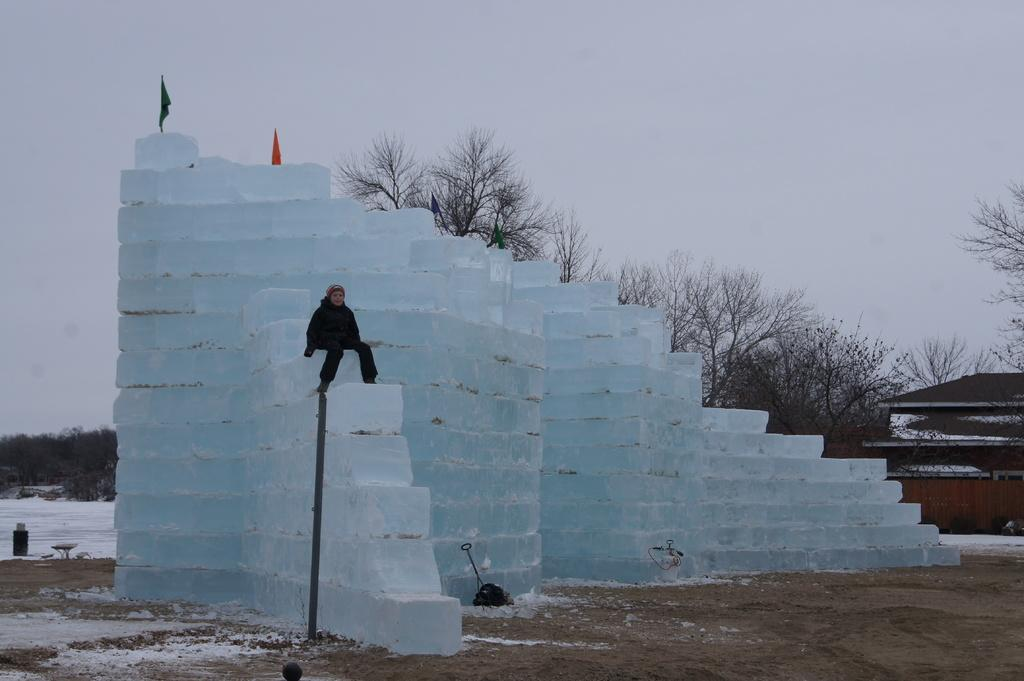What type of structure is visible in the image? There is a house in the image. What natural elements can be seen in the image? There are trees and snow on the ground in the image. Where is the woman sitting in the image? The woman is sitting on an ice brick wall in the image. What is the condition of the sky in the image? The sky is cloudy in the image. Can you tell me how many plants are being watered by the woman's uncle in the image? There is no uncle or plant present in the image, and therefore no such activity can be observed. 